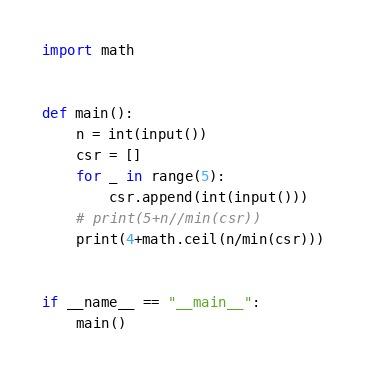Convert code to text. <code><loc_0><loc_0><loc_500><loc_500><_Python_>import math


def main():
    n = int(input())
    csr = []
    for _ in range(5):
        csr.append(int(input()))
    # print(5+n//min(csr))
    print(4+math.ceil(n/min(csr)))


if __name__ == "__main__":
    main()
</code> 